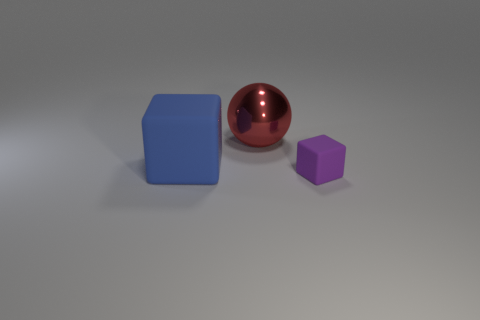Are there any other things that have the same size as the purple block?
Your response must be concise. No. How many large balls have the same color as the tiny rubber thing?
Provide a succinct answer. 0. Is the number of purple matte objects greater than the number of big yellow cylinders?
Your answer should be compact. Yes. What material is the ball?
Your answer should be compact. Metal. There is a rubber object left of the red thing; does it have the same size as the small purple block?
Offer a very short reply. No. How big is the thing behind the large rubber thing?
Ensure brevity in your answer.  Large. Is there any other thing that is the same material as the red sphere?
Give a very brief answer. No. What number of big matte objects are there?
Provide a short and direct response. 1. Does the tiny matte cube have the same color as the shiny sphere?
Keep it short and to the point. No. The object that is to the right of the blue rubber cube and to the left of the tiny purple matte block is what color?
Your answer should be compact. Red. 